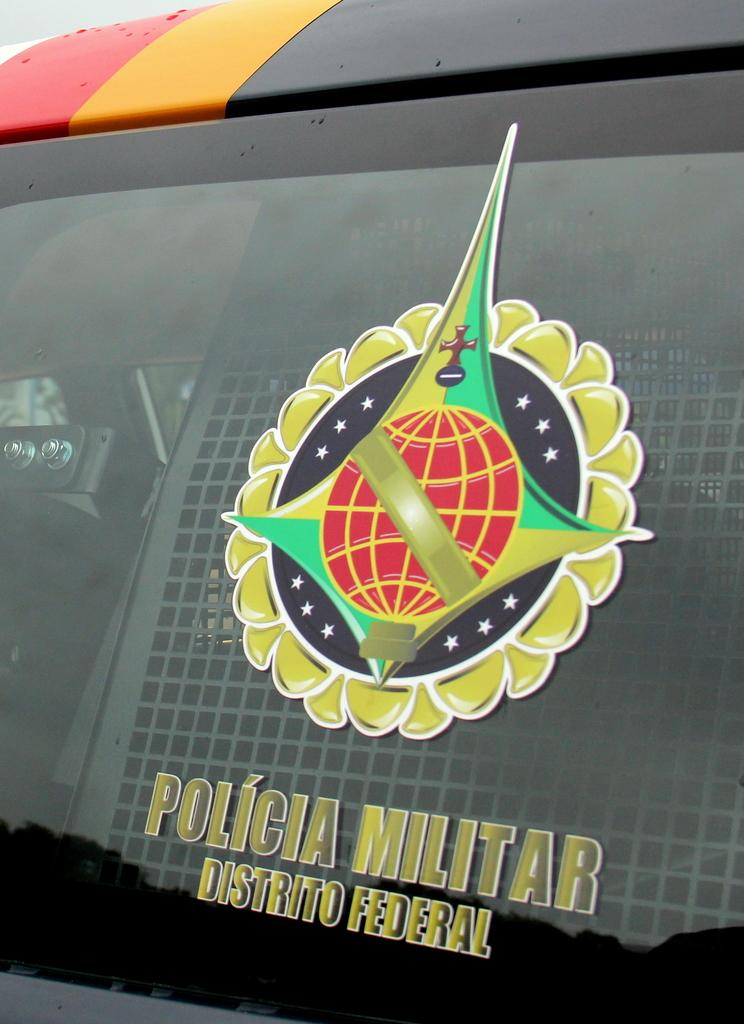Provide a one-sentence caption for the provided image. A picture on a window that reads Policia Militar Distrito Federal. 